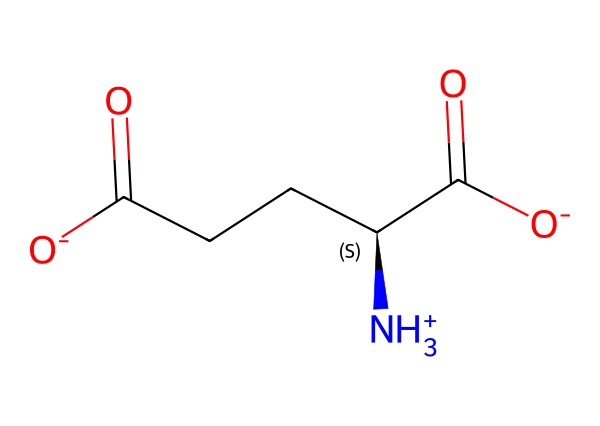What is the total number of carbon atoms in this molecule? The SMILES representation indicates the presence of several carbon atoms. By analyzing the structure, we can identify that there are four carbon atoms in this molecule, as denoted by the different alkyl groups.
Answer: four How many functional groups are present in the molecule? Examining the SMILES, the molecule contains two carboxylic acid functional groups (-COOH) and one ammonium group (-NH3+). Therefore, there are three functional groups in total.
Answer: three What type of molecule is represented by this SMILES? The presence of a positively charged ammonium ion and both carboxylic acid groups suggests that this molecule is an amino acid, specifically glutamate.
Answer: amino acid How does the presence of the ammonium group affect the charge of the molecule? The ammonium group is positively charged ([NH3+]), and the two carboxylic acid groups each carry a negative charge ([O-]). This results in an overall neutral charge when summed.
Answer: neutral What functional group in this structure enhances umami taste? The presence of the carboxylic acid functional groups (-COOH) is directly related to the flavor of umami, as these groups are known to contribute to the savory taste in foods like traditional Japanese seasonings.
Answer: carboxylic acid Which carbon atom is chiral in this molecule? In the structure represented by the SMILES, the carbon that is attached to both an ammonium group, another carbon chain, and two carboxylic acid groups is the one that exhibits chirality. This is identified by the presence of four different substituents on that carbon.
Answer: chiral carbon 